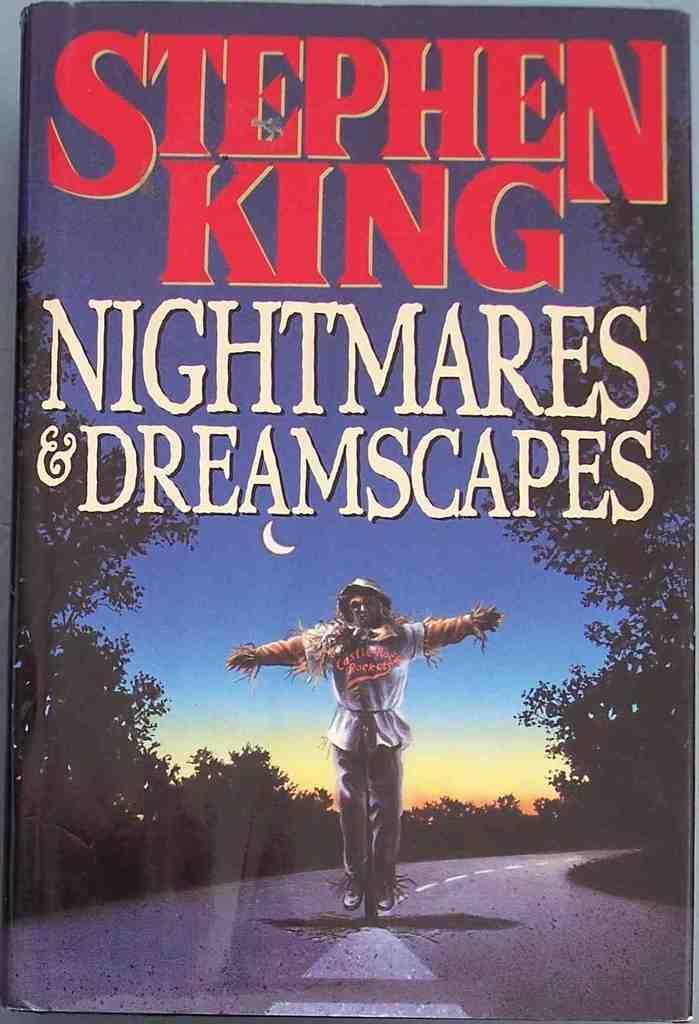How would you summarize this image in a sentence or two? In this image we can see a book. On the cover page of the image we can see many trees and plants. There is a sky and a moon in the image. There is some text on the book. There is a scarecrow in the image. 